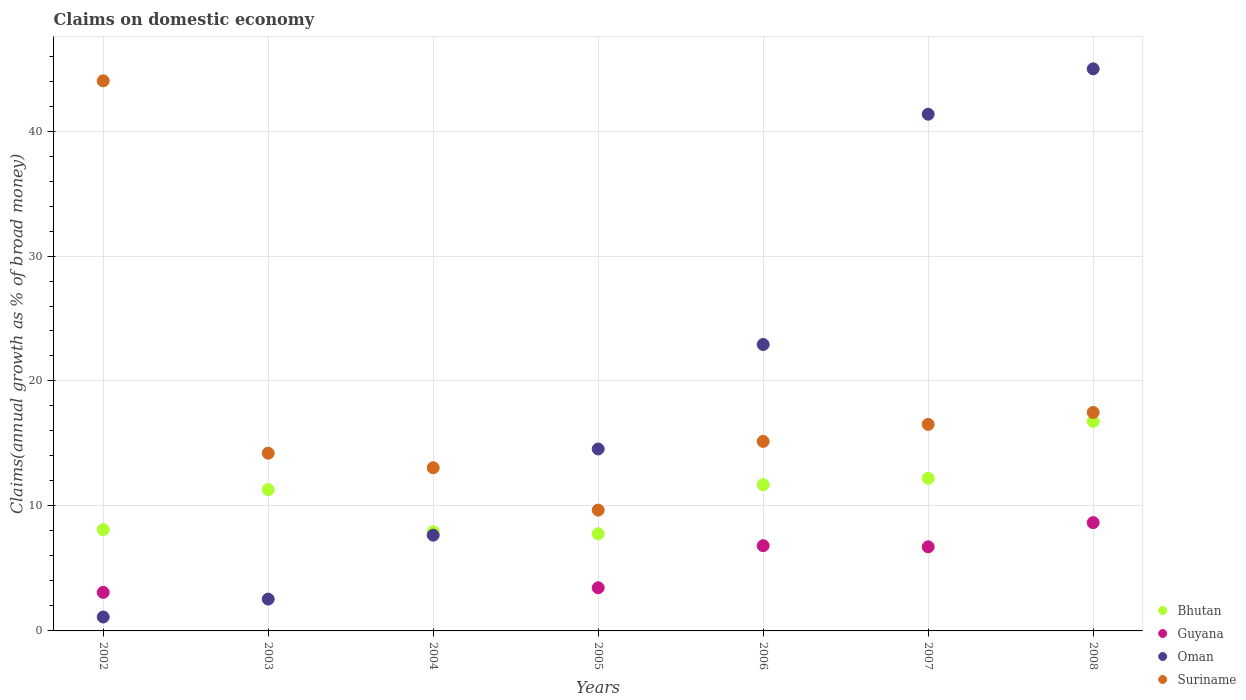Is the number of dotlines equal to the number of legend labels?
Offer a very short reply. No. What is the percentage of broad money claimed on domestic economy in Guyana in 2002?
Offer a very short reply. 3.08. Across all years, what is the maximum percentage of broad money claimed on domestic economy in Suriname?
Make the answer very short. 44.02. Across all years, what is the minimum percentage of broad money claimed on domestic economy in Oman?
Offer a very short reply. 1.11. What is the total percentage of broad money claimed on domestic economy in Oman in the graph?
Your answer should be compact. 135.13. What is the difference between the percentage of broad money claimed on domestic economy in Guyana in 2005 and that in 2006?
Provide a short and direct response. -3.37. What is the difference between the percentage of broad money claimed on domestic economy in Oman in 2003 and the percentage of broad money claimed on domestic economy in Guyana in 2007?
Your response must be concise. -4.18. What is the average percentage of broad money claimed on domestic economy in Suriname per year?
Your answer should be very brief. 18.59. In the year 2004, what is the difference between the percentage of broad money claimed on domestic economy in Bhutan and percentage of broad money claimed on domestic economy in Suriname?
Provide a succinct answer. -5.12. In how many years, is the percentage of broad money claimed on domestic economy in Guyana greater than 40 %?
Ensure brevity in your answer.  0. What is the ratio of the percentage of broad money claimed on domestic economy in Oman in 2003 to that in 2005?
Your answer should be very brief. 0.17. Is the percentage of broad money claimed on domestic economy in Suriname in 2005 less than that in 2006?
Provide a succinct answer. Yes. What is the difference between the highest and the second highest percentage of broad money claimed on domestic economy in Oman?
Keep it short and to the point. 3.63. What is the difference between the highest and the lowest percentage of broad money claimed on domestic economy in Bhutan?
Provide a short and direct response. 8.99. In how many years, is the percentage of broad money claimed on domestic economy in Suriname greater than the average percentage of broad money claimed on domestic economy in Suriname taken over all years?
Provide a succinct answer. 1. Is it the case that in every year, the sum of the percentage of broad money claimed on domestic economy in Bhutan and percentage of broad money claimed on domestic economy in Guyana  is greater than the sum of percentage of broad money claimed on domestic economy in Oman and percentage of broad money claimed on domestic economy in Suriname?
Your answer should be very brief. No. Is it the case that in every year, the sum of the percentage of broad money claimed on domestic economy in Guyana and percentage of broad money claimed on domestic economy in Oman  is greater than the percentage of broad money claimed on domestic economy in Bhutan?
Offer a terse response. No. Does the percentage of broad money claimed on domestic economy in Oman monotonically increase over the years?
Provide a succinct answer. Yes. Is the percentage of broad money claimed on domestic economy in Bhutan strictly greater than the percentage of broad money claimed on domestic economy in Suriname over the years?
Offer a very short reply. No. Is the percentage of broad money claimed on domestic economy in Oman strictly less than the percentage of broad money claimed on domestic economy in Bhutan over the years?
Your response must be concise. No. How many years are there in the graph?
Keep it short and to the point. 7. Are the values on the major ticks of Y-axis written in scientific E-notation?
Ensure brevity in your answer.  No. Does the graph contain grids?
Offer a terse response. Yes. Where does the legend appear in the graph?
Ensure brevity in your answer.  Bottom right. How are the legend labels stacked?
Your answer should be compact. Vertical. What is the title of the graph?
Your response must be concise. Claims on domestic economy. What is the label or title of the Y-axis?
Provide a short and direct response. Claims(annual growth as % of broad money). What is the Claims(annual growth as % of broad money) of Bhutan in 2002?
Ensure brevity in your answer.  8.11. What is the Claims(annual growth as % of broad money) in Guyana in 2002?
Your response must be concise. 3.08. What is the Claims(annual growth as % of broad money) in Oman in 2002?
Offer a terse response. 1.11. What is the Claims(annual growth as % of broad money) in Suriname in 2002?
Your response must be concise. 44.02. What is the Claims(annual growth as % of broad money) of Bhutan in 2003?
Provide a short and direct response. 11.31. What is the Claims(annual growth as % of broad money) in Oman in 2003?
Provide a succinct answer. 2.55. What is the Claims(annual growth as % of broad money) of Suriname in 2003?
Make the answer very short. 14.23. What is the Claims(annual growth as % of broad money) in Bhutan in 2004?
Give a very brief answer. 7.94. What is the Claims(annual growth as % of broad money) of Guyana in 2004?
Keep it short and to the point. 0. What is the Claims(annual growth as % of broad money) of Oman in 2004?
Keep it short and to the point. 7.66. What is the Claims(annual growth as % of broad money) of Suriname in 2004?
Your answer should be compact. 13.06. What is the Claims(annual growth as % of broad money) of Bhutan in 2005?
Give a very brief answer. 7.77. What is the Claims(annual growth as % of broad money) in Guyana in 2005?
Provide a succinct answer. 3.46. What is the Claims(annual growth as % of broad money) of Oman in 2005?
Your answer should be compact. 14.56. What is the Claims(annual growth as % of broad money) of Suriname in 2005?
Give a very brief answer. 9.67. What is the Claims(annual growth as % of broad money) of Bhutan in 2006?
Your response must be concise. 11.7. What is the Claims(annual growth as % of broad money) of Guyana in 2006?
Make the answer very short. 6.82. What is the Claims(annual growth as % of broad money) in Oman in 2006?
Ensure brevity in your answer.  22.92. What is the Claims(annual growth as % of broad money) in Suriname in 2006?
Your answer should be compact. 15.16. What is the Claims(annual growth as % of broad money) in Bhutan in 2007?
Make the answer very short. 12.21. What is the Claims(annual growth as % of broad money) of Guyana in 2007?
Provide a short and direct response. 6.73. What is the Claims(annual growth as % of broad money) in Oman in 2007?
Give a very brief answer. 41.35. What is the Claims(annual growth as % of broad money) of Suriname in 2007?
Offer a terse response. 16.53. What is the Claims(annual growth as % of broad money) of Bhutan in 2008?
Your response must be concise. 16.77. What is the Claims(annual growth as % of broad money) in Guyana in 2008?
Provide a short and direct response. 8.67. What is the Claims(annual growth as % of broad money) of Oman in 2008?
Give a very brief answer. 44.98. What is the Claims(annual growth as % of broad money) in Suriname in 2008?
Provide a short and direct response. 17.48. Across all years, what is the maximum Claims(annual growth as % of broad money) of Bhutan?
Your answer should be very brief. 16.77. Across all years, what is the maximum Claims(annual growth as % of broad money) of Guyana?
Your response must be concise. 8.67. Across all years, what is the maximum Claims(annual growth as % of broad money) of Oman?
Your response must be concise. 44.98. Across all years, what is the maximum Claims(annual growth as % of broad money) in Suriname?
Give a very brief answer. 44.02. Across all years, what is the minimum Claims(annual growth as % of broad money) of Bhutan?
Offer a very short reply. 7.77. Across all years, what is the minimum Claims(annual growth as % of broad money) of Oman?
Provide a succinct answer. 1.11. Across all years, what is the minimum Claims(annual growth as % of broad money) of Suriname?
Provide a short and direct response. 9.67. What is the total Claims(annual growth as % of broad money) of Bhutan in the graph?
Your answer should be compact. 75.81. What is the total Claims(annual growth as % of broad money) in Guyana in the graph?
Your answer should be compact. 28.76. What is the total Claims(annual growth as % of broad money) of Oman in the graph?
Make the answer very short. 135.13. What is the total Claims(annual growth as % of broad money) in Suriname in the graph?
Keep it short and to the point. 130.14. What is the difference between the Claims(annual growth as % of broad money) in Bhutan in 2002 and that in 2003?
Provide a succinct answer. -3.2. What is the difference between the Claims(annual growth as % of broad money) of Oman in 2002 and that in 2003?
Keep it short and to the point. -1.43. What is the difference between the Claims(annual growth as % of broad money) of Suriname in 2002 and that in 2003?
Your answer should be very brief. 29.79. What is the difference between the Claims(annual growth as % of broad money) of Bhutan in 2002 and that in 2004?
Make the answer very short. 0.17. What is the difference between the Claims(annual growth as % of broad money) in Oman in 2002 and that in 2004?
Make the answer very short. -6.55. What is the difference between the Claims(annual growth as % of broad money) of Suriname in 2002 and that in 2004?
Offer a terse response. 30.96. What is the difference between the Claims(annual growth as % of broad money) in Bhutan in 2002 and that in 2005?
Give a very brief answer. 0.33. What is the difference between the Claims(annual growth as % of broad money) in Guyana in 2002 and that in 2005?
Offer a very short reply. -0.37. What is the difference between the Claims(annual growth as % of broad money) of Oman in 2002 and that in 2005?
Offer a very short reply. -13.45. What is the difference between the Claims(annual growth as % of broad money) in Suriname in 2002 and that in 2005?
Provide a succinct answer. 34.35. What is the difference between the Claims(annual growth as % of broad money) of Bhutan in 2002 and that in 2006?
Make the answer very short. -3.6. What is the difference between the Claims(annual growth as % of broad money) of Guyana in 2002 and that in 2006?
Make the answer very short. -3.74. What is the difference between the Claims(annual growth as % of broad money) of Oman in 2002 and that in 2006?
Your answer should be very brief. -21.81. What is the difference between the Claims(annual growth as % of broad money) of Suriname in 2002 and that in 2006?
Offer a very short reply. 28.86. What is the difference between the Claims(annual growth as % of broad money) in Bhutan in 2002 and that in 2007?
Ensure brevity in your answer.  -4.11. What is the difference between the Claims(annual growth as % of broad money) in Guyana in 2002 and that in 2007?
Provide a short and direct response. -3.65. What is the difference between the Claims(annual growth as % of broad money) of Oman in 2002 and that in 2007?
Provide a succinct answer. -40.23. What is the difference between the Claims(annual growth as % of broad money) in Suriname in 2002 and that in 2007?
Your answer should be very brief. 27.49. What is the difference between the Claims(annual growth as % of broad money) of Bhutan in 2002 and that in 2008?
Provide a succinct answer. -8.66. What is the difference between the Claims(annual growth as % of broad money) of Guyana in 2002 and that in 2008?
Your answer should be very brief. -5.58. What is the difference between the Claims(annual growth as % of broad money) of Oman in 2002 and that in 2008?
Your answer should be compact. -43.86. What is the difference between the Claims(annual growth as % of broad money) of Suriname in 2002 and that in 2008?
Make the answer very short. 26.54. What is the difference between the Claims(annual growth as % of broad money) of Bhutan in 2003 and that in 2004?
Give a very brief answer. 3.37. What is the difference between the Claims(annual growth as % of broad money) of Oman in 2003 and that in 2004?
Provide a short and direct response. -5.12. What is the difference between the Claims(annual growth as % of broad money) in Suriname in 2003 and that in 2004?
Make the answer very short. 1.17. What is the difference between the Claims(annual growth as % of broad money) of Bhutan in 2003 and that in 2005?
Provide a short and direct response. 3.54. What is the difference between the Claims(annual growth as % of broad money) of Oman in 2003 and that in 2005?
Provide a succinct answer. -12.01. What is the difference between the Claims(annual growth as % of broad money) of Suriname in 2003 and that in 2005?
Offer a terse response. 4.56. What is the difference between the Claims(annual growth as % of broad money) in Bhutan in 2003 and that in 2006?
Offer a very short reply. -0.39. What is the difference between the Claims(annual growth as % of broad money) of Oman in 2003 and that in 2006?
Provide a short and direct response. -20.37. What is the difference between the Claims(annual growth as % of broad money) in Suriname in 2003 and that in 2006?
Your answer should be compact. -0.94. What is the difference between the Claims(annual growth as % of broad money) in Bhutan in 2003 and that in 2007?
Offer a very short reply. -0.91. What is the difference between the Claims(annual growth as % of broad money) in Oman in 2003 and that in 2007?
Your response must be concise. -38.8. What is the difference between the Claims(annual growth as % of broad money) in Suriname in 2003 and that in 2007?
Your answer should be very brief. -2.3. What is the difference between the Claims(annual growth as % of broad money) in Bhutan in 2003 and that in 2008?
Your answer should be very brief. -5.46. What is the difference between the Claims(annual growth as % of broad money) of Oman in 2003 and that in 2008?
Give a very brief answer. -42.43. What is the difference between the Claims(annual growth as % of broad money) in Suriname in 2003 and that in 2008?
Your response must be concise. -3.26. What is the difference between the Claims(annual growth as % of broad money) in Bhutan in 2004 and that in 2005?
Keep it short and to the point. 0.17. What is the difference between the Claims(annual growth as % of broad money) of Oman in 2004 and that in 2005?
Provide a short and direct response. -6.9. What is the difference between the Claims(annual growth as % of broad money) of Suriname in 2004 and that in 2005?
Make the answer very short. 3.39. What is the difference between the Claims(annual growth as % of broad money) of Bhutan in 2004 and that in 2006?
Your answer should be very brief. -3.76. What is the difference between the Claims(annual growth as % of broad money) of Oman in 2004 and that in 2006?
Provide a succinct answer. -15.26. What is the difference between the Claims(annual growth as % of broad money) in Suriname in 2004 and that in 2006?
Give a very brief answer. -2.11. What is the difference between the Claims(annual growth as % of broad money) in Bhutan in 2004 and that in 2007?
Keep it short and to the point. -4.28. What is the difference between the Claims(annual growth as % of broad money) of Oman in 2004 and that in 2007?
Your answer should be compact. -33.68. What is the difference between the Claims(annual growth as % of broad money) in Suriname in 2004 and that in 2007?
Offer a terse response. -3.47. What is the difference between the Claims(annual growth as % of broad money) of Bhutan in 2004 and that in 2008?
Make the answer very short. -8.83. What is the difference between the Claims(annual growth as % of broad money) of Oman in 2004 and that in 2008?
Give a very brief answer. -37.31. What is the difference between the Claims(annual growth as % of broad money) of Suriname in 2004 and that in 2008?
Your answer should be compact. -4.43. What is the difference between the Claims(annual growth as % of broad money) in Bhutan in 2005 and that in 2006?
Provide a short and direct response. -3.93. What is the difference between the Claims(annual growth as % of broad money) of Guyana in 2005 and that in 2006?
Your response must be concise. -3.37. What is the difference between the Claims(annual growth as % of broad money) in Oman in 2005 and that in 2006?
Ensure brevity in your answer.  -8.36. What is the difference between the Claims(annual growth as % of broad money) in Suriname in 2005 and that in 2006?
Your response must be concise. -5.5. What is the difference between the Claims(annual growth as % of broad money) in Bhutan in 2005 and that in 2007?
Offer a very short reply. -4.44. What is the difference between the Claims(annual growth as % of broad money) in Guyana in 2005 and that in 2007?
Provide a succinct answer. -3.27. What is the difference between the Claims(annual growth as % of broad money) in Oman in 2005 and that in 2007?
Offer a very short reply. -26.79. What is the difference between the Claims(annual growth as % of broad money) of Suriname in 2005 and that in 2007?
Provide a succinct answer. -6.86. What is the difference between the Claims(annual growth as % of broad money) in Bhutan in 2005 and that in 2008?
Provide a short and direct response. -8.99. What is the difference between the Claims(annual growth as % of broad money) in Guyana in 2005 and that in 2008?
Make the answer very short. -5.21. What is the difference between the Claims(annual growth as % of broad money) of Oman in 2005 and that in 2008?
Offer a very short reply. -30.42. What is the difference between the Claims(annual growth as % of broad money) of Suriname in 2005 and that in 2008?
Offer a terse response. -7.82. What is the difference between the Claims(annual growth as % of broad money) of Bhutan in 2006 and that in 2007?
Your response must be concise. -0.51. What is the difference between the Claims(annual growth as % of broad money) of Guyana in 2006 and that in 2007?
Your answer should be compact. 0.09. What is the difference between the Claims(annual growth as % of broad money) in Oman in 2006 and that in 2007?
Provide a short and direct response. -18.43. What is the difference between the Claims(annual growth as % of broad money) in Suriname in 2006 and that in 2007?
Your answer should be very brief. -1.36. What is the difference between the Claims(annual growth as % of broad money) in Bhutan in 2006 and that in 2008?
Offer a terse response. -5.06. What is the difference between the Claims(annual growth as % of broad money) in Guyana in 2006 and that in 2008?
Your answer should be very brief. -1.85. What is the difference between the Claims(annual growth as % of broad money) of Oman in 2006 and that in 2008?
Your answer should be very brief. -22.06. What is the difference between the Claims(annual growth as % of broad money) in Suriname in 2006 and that in 2008?
Give a very brief answer. -2.32. What is the difference between the Claims(annual growth as % of broad money) of Bhutan in 2007 and that in 2008?
Your response must be concise. -4.55. What is the difference between the Claims(annual growth as % of broad money) of Guyana in 2007 and that in 2008?
Give a very brief answer. -1.94. What is the difference between the Claims(annual growth as % of broad money) of Oman in 2007 and that in 2008?
Provide a short and direct response. -3.63. What is the difference between the Claims(annual growth as % of broad money) in Suriname in 2007 and that in 2008?
Offer a very short reply. -0.96. What is the difference between the Claims(annual growth as % of broad money) in Bhutan in 2002 and the Claims(annual growth as % of broad money) in Oman in 2003?
Offer a very short reply. 5.56. What is the difference between the Claims(annual growth as % of broad money) in Bhutan in 2002 and the Claims(annual growth as % of broad money) in Suriname in 2003?
Provide a succinct answer. -6.12. What is the difference between the Claims(annual growth as % of broad money) in Guyana in 2002 and the Claims(annual growth as % of broad money) in Oman in 2003?
Provide a short and direct response. 0.54. What is the difference between the Claims(annual growth as % of broad money) of Guyana in 2002 and the Claims(annual growth as % of broad money) of Suriname in 2003?
Give a very brief answer. -11.14. What is the difference between the Claims(annual growth as % of broad money) of Oman in 2002 and the Claims(annual growth as % of broad money) of Suriname in 2003?
Provide a short and direct response. -13.11. What is the difference between the Claims(annual growth as % of broad money) of Bhutan in 2002 and the Claims(annual growth as % of broad money) of Oman in 2004?
Provide a short and direct response. 0.44. What is the difference between the Claims(annual growth as % of broad money) in Bhutan in 2002 and the Claims(annual growth as % of broad money) in Suriname in 2004?
Offer a very short reply. -4.95. What is the difference between the Claims(annual growth as % of broad money) of Guyana in 2002 and the Claims(annual growth as % of broad money) of Oman in 2004?
Provide a succinct answer. -4.58. What is the difference between the Claims(annual growth as % of broad money) in Guyana in 2002 and the Claims(annual growth as % of broad money) in Suriname in 2004?
Provide a short and direct response. -9.97. What is the difference between the Claims(annual growth as % of broad money) in Oman in 2002 and the Claims(annual growth as % of broad money) in Suriname in 2004?
Provide a succinct answer. -11.94. What is the difference between the Claims(annual growth as % of broad money) of Bhutan in 2002 and the Claims(annual growth as % of broad money) of Guyana in 2005?
Provide a short and direct response. 4.65. What is the difference between the Claims(annual growth as % of broad money) in Bhutan in 2002 and the Claims(annual growth as % of broad money) in Oman in 2005?
Your response must be concise. -6.45. What is the difference between the Claims(annual growth as % of broad money) of Bhutan in 2002 and the Claims(annual growth as % of broad money) of Suriname in 2005?
Provide a succinct answer. -1.56. What is the difference between the Claims(annual growth as % of broad money) in Guyana in 2002 and the Claims(annual growth as % of broad money) in Oman in 2005?
Your response must be concise. -11.48. What is the difference between the Claims(annual growth as % of broad money) of Guyana in 2002 and the Claims(annual growth as % of broad money) of Suriname in 2005?
Ensure brevity in your answer.  -6.58. What is the difference between the Claims(annual growth as % of broad money) of Oman in 2002 and the Claims(annual growth as % of broad money) of Suriname in 2005?
Your response must be concise. -8.55. What is the difference between the Claims(annual growth as % of broad money) of Bhutan in 2002 and the Claims(annual growth as % of broad money) of Guyana in 2006?
Offer a terse response. 1.29. What is the difference between the Claims(annual growth as % of broad money) in Bhutan in 2002 and the Claims(annual growth as % of broad money) in Oman in 2006?
Provide a short and direct response. -14.81. What is the difference between the Claims(annual growth as % of broad money) of Bhutan in 2002 and the Claims(annual growth as % of broad money) of Suriname in 2006?
Keep it short and to the point. -7.06. What is the difference between the Claims(annual growth as % of broad money) of Guyana in 2002 and the Claims(annual growth as % of broad money) of Oman in 2006?
Your answer should be very brief. -19.84. What is the difference between the Claims(annual growth as % of broad money) of Guyana in 2002 and the Claims(annual growth as % of broad money) of Suriname in 2006?
Offer a very short reply. -12.08. What is the difference between the Claims(annual growth as % of broad money) of Oman in 2002 and the Claims(annual growth as % of broad money) of Suriname in 2006?
Provide a succinct answer. -14.05. What is the difference between the Claims(annual growth as % of broad money) of Bhutan in 2002 and the Claims(annual growth as % of broad money) of Guyana in 2007?
Give a very brief answer. 1.38. What is the difference between the Claims(annual growth as % of broad money) in Bhutan in 2002 and the Claims(annual growth as % of broad money) in Oman in 2007?
Provide a short and direct response. -33.24. What is the difference between the Claims(annual growth as % of broad money) in Bhutan in 2002 and the Claims(annual growth as % of broad money) in Suriname in 2007?
Offer a terse response. -8.42. What is the difference between the Claims(annual growth as % of broad money) of Guyana in 2002 and the Claims(annual growth as % of broad money) of Oman in 2007?
Offer a terse response. -38.26. What is the difference between the Claims(annual growth as % of broad money) of Guyana in 2002 and the Claims(annual growth as % of broad money) of Suriname in 2007?
Your answer should be very brief. -13.44. What is the difference between the Claims(annual growth as % of broad money) of Oman in 2002 and the Claims(annual growth as % of broad money) of Suriname in 2007?
Your answer should be very brief. -15.41. What is the difference between the Claims(annual growth as % of broad money) in Bhutan in 2002 and the Claims(annual growth as % of broad money) in Guyana in 2008?
Your response must be concise. -0.56. What is the difference between the Claims(annual growth as % of broad money) of Bhutan in 2002 and the Claims(annual growth as % of broad money) of Oman in 2008?
Keep it short and to the point. -36.87. What is the difference between the Claims(annual growth as % of broad money) in Bhutan in 2002 and the Claims(annual growth as % of broad money) in Suriname in 2008?
Provide a succinct answer. -9.37. What is the difference between the Claims(annual growth as % of broad money) of Guyana in 2002 and the Claims(annual growth as % of broad money) of Oman in 2008?
Offer a terse response. -41.89. What is the difference between the Claims(annual growth as % of broad money) in Guyana in 2002 and the Claims(annual growth as % of broad money) in Suriname in 2008?
Give a very brief answer. -14.4. What is the difference between the Claims(annual growth as % of broad money) of Oman in 2002 and the Claims(annual growth as % of broad money) of Suriname in 2008?
Make the answer very short. -16.37. What is the difference between the Claims(annual growth as % of broad money) in Bhutan in 2003 and the Claims(annual growth as % of broad money) in Oman in 2004?
Make the answer very short. 3.65. What is the difference between the Claims(annual growth as % of broad money) of Bhutan in 2003 and the Claims(annual growth as % of broad money) of Suriname in 2004?
Provide a short and direct response. -1.75. What is the difference between the Claims(annual growth as % of broad money) of Oman in 2003 and the Claims(annual growth as % of broad money) of Suriname in 2004?
Your answer should be very brief. -10.51. What is the difference between the Claims(annual growth as % of broad money) in Bhutan in 2003 and the Claims(annual growth as % of broad money) in Guyana in 2005?
Provide a succinct answer. 7.85. What is the difference between the Claims(annual growth as % of broad money) of Bhutan in 2003 and the Claims(annual growth as % of broad money) of Oman in 2005?
Offer a terse response. -3.25. What is the difference between the Claims(annual growth as % of broad money) of Bhutan in 2003 and the Claims(annual growth as % of broad money) of Suriname in 2005?
Ensure brevity in your answer.  1.64. What is the difference between the Claims(annual growth as % of broad money) of Oman in 2003 and the Claims(annual growth as % of broad money) of Suriname in 2005?
Provide a short and direct response. -7.12. What is the difference between the Claims(annual growth as % of broad money) of Bhutan in 2003 and the Claims(annual growth as % of broad money) of Guyana in 2006?
Your response must be concise. 4.49. What is the difference between the Claims(annual growth as % of broad money) in Bhutan in 2003 and the Claims(annual growth as % of broad money) in Oman in 2006?
Offer a very short reply. -11.61. What is the difference between the Claims(annual growth as % of broad money) of Bhutan in 2003 and the Claims(annual growth as % of broad money) of Suriname in 2006?
Give a very brief answer. -3.86. What is the difference between the Claims(annual growth as % of broad money) in Oman in 2003 and the Claims(annual growth as % of broad money) in Suriname in 2006?
Your answer should be compact. -12.62. What is the difference between the Claims(annual growth as % of broad money) in Bhutan in 2003 and the Claims(annual growth as % of broad money) in Guyana in 2007?
Keep it short and to the point. 4.58. What is the difference between the Claims(annual growth as % of broad money) in Bhutan in 2003 and the Claims(annual growth as % of broad money) in Oman in 2007?
Keep it short and to the point. -30.04. What is the difference between the Claims(annual growth as % of broad money) in Bhutan in 2003 and the Claims(annual growth as % of broad money) in Suriname in 2007?
Offer a terse response. -5.22. What is the difference between the Claims(annual growth as % of broad money) of Oman in 2003 and the Claims(annual growth as % of broad money) of Suriname in 2007?
Give a very brief answer. -13.98. What is the difference between the Claims(annual growth as % of broad money) of Bhutan in 2003 and the Claims(annual growth as % of broad money) of Guyana in 2008?
Provide a succinct answer. 2.64. What is the difference between the Claims(annual growth as % of broad money) in Bhutan in 2003 and the Claims(annual growth as % of broad money) in Oman in 2008?
Your answer should be very brief. -33.67. What is the difference between the Claims(annual growth as % of broad money) of Bhutan in 2003 and the Claims(annual growth as % of broad money) of Suriname in 2008?
Offer a very short reply. -6.17. What is the difference between the Claims(annual growth as % of broad money) in Oman in 2003 and the Claims(annual growth as % of broad money) in Suriname in 2008?
Keep it short and to the point. -14.93. What is the difference between the Claims(annual growth as % of broad money) in Bhutan in 2004 and the Claims(annual growth as % of broad money) in Guyana in 2005?
Ensure brevity in your answer.  4.48. What is the difference between the Claims(annual growth as % of broad money) of Bhutan in 2004 and the Claims(annual growth as % of broad money) of Oman in 2005?
Provide a succinct answer. -6.62. What is the difference between the Claims(annual growth as % of broad money) in Bhutan in 2004 and the Claims(annual growth as % of broad money) in Suriname in 2005?
Provide a succinct answer. -1.73. What is the difference between the Claims(annual growth as % of broad money) of Oman in 2004 and the Claims(annual growth as % of broad money) of Suriname in 2005?
Make the answer very short. -2. What is the difference between the Claims(annual growth as % of broad money) in Bhutan in 2004 and the Claims(annual growth as % of broad money) in Guyana in 2006?
Provide a succinct answer. 1.12. What is the difference between the Claims(annual growth as % of broad money) of Bhutan in 2004 and the Claims(annual growth as % of broad money) of Oman in 2006?
Keep it short and to the point. -14.98. What is the difference between the Claims(annual growth as % of broad money) in Bhutan in 2004 and the Claims(annual growth as % of broad money) in Suriname in 2006?
Provide a succinct answer. -7.23. What is the difference between the Claims(annual growth as % of broad money) of Oman in 2004 and the Claims(annual growth as % of broad money) of Suriname in 2006?
Provide a short and direct response. -7.5. What is the difference between the Claims(annual growth as % of broad money) in Bhutan in 2004 and the Claims(annual growth as % of broad money) in Guyana in 2007?
Provide a short and direct response. 1.21. What is the difference between the Claims(annual growth as % of broad money) of Bhutan in 2004 and the Claims(annual growth as % of broad money) of Oman in 2007?
Ensure brevity in your answer.  -33.41. What is the difference between the Claims(annual growth as % of broad money) of Bhutan in 2004 and the Claims(annual growth as % of broad money) of Suriname in 2007?
Provide a succinct answer. -8.59. What is the difference between the Claims(annual growth as % of broad money) in Oman in 2004 and the Claims(annual growth as % of broad money) in Suriname in 2007?
Your response must be concise. -8.86. What is the difference between the Claims(annual growth as % of broad money) of Bhutan in 2004 and the Claims(annual growth as % of broad money) of Guyana in 2008?
Offer a terse response. -0.73. What is the difference between the Claims(annual growth as % of broad money) of Bhutan in 2004 and the Claims(annual growth as % of broad money) of Oman in 2008?
Make the answer very short. -37.04. What is the difference between the Claims(annual growth as % of broad money) of Bhutan in 2004 and the Claims(annual growth as % of broad money) of Suriname in 2008?
Offer a terse response. -9.54. What is the difference between the Claims(annual growth as % of broad money) in Oman in 2004 and the Claims(annual growth as % of broad money) in Suriname in 2008?
Keep it short and to the point. -9.82. What is the difference between the Claims(annual growth as % of broad money) of Bhutan in 2005 and the Claims(annual growth as % of broad money) of Guyana in 2006?
Your response must be concise. 0.95. What is the difference between the Claims(annual growth as % of broad money) of Bhutan in 2005 and the Claims(annual growth as % of broad money) of Oman in 2006?
Offer a very short reply. -15.15. What is the difference between the Claims(annual growth as % of broad money) in Bhutan in 2005 and the Claims(annual growth as % of broad money) in Suriname in 2006?
Offer a terse response. -7.39. What is the difference between the Claims(annual growth as % of broad money) of Guyana in 2005 and the Claims(annual growth as % of broad money) of Oman in 2006?
Offer a very short reply. -19.46. What is the difference between the Claims(annual growth as % of broad money) of Guyana in 2005 and the Claims(annual growth as % of broad money) of Suriname in 2006?
Give a very brief answer. -11.71. What is the difference between the Claims(annual growth as % of broad money) in Oman in 2005 and the Claims(annual growth as % of broad money) in Suriname in 2006?
Provide a succinct answer. -0.6. What is the difference between the Claims(annual growth as % of broad money) in Bhutan in 2005 and the Claims(annual growth as % of broad money) in Guyana in 2007?
Give a very brief answer. 1.04. What is the difference between the Claims(annual growth as % of broad money) of Bhutan in 2005 and the Claims(annual growth as % of broad money) of Oman in 2007?
Provide a short and direct response. -33.58. What is the difference between the Claims(annual growth as % of broad money) of Bhutan in 2005 and the Claims(annual growth as % of broad money) of Suriname in 2007?
Provide a succinct answer. -8.75. What is the difference between the Claims(annual growth as % of broad money) of Guyana in 2005 and the Claims(annual growth as % of broad money) of Oman in 2007?
Your response must be concise. -37.89. What is the difference between the Claims(annual growth as % of broad money) of Guyana in 2005 and the Claims(annual growth as % of broad money) of Suriname in 2007?
Your answer should be compact. -13.07. What is the difference between the Claims(annual growth as % of broad money) in Oman in 2005 and the Claims(annual growth as % of broad money) in Suriname in 2007?
Provide a short and direct response. -1.97. What is the difference between the Claims(annual growth as % of broad money) in Bhutan in 2005 and the Claims(annual growth as % of broad money) in Guyana in 2008?
Keep it short and to the point. -0.89. What is the difference between the Claims(annual growth as % of broad money) in Bhutan in 2005 and the Claims(annual growth as % of broad money) in Oman in 2008?
Offer a very short reply. -37.2. What is the difference between the Claims(annual growth as % of broad money) of Bhutan in 2005 and the Claims(annual growth as % of broad money) of Suriname in 2008?
Provide a succinct answer. -9.71. What is the difference between the Claims(annual growth as % of broad money) of Guyana in 2005 and the Claims(annual growth as % of broad money) of Oman in 2008?
Offer a terse response. -41.52. What is the difference between the Claims(annual growth as % of broad money) in Guyana in 2005 and the Claims(annual growth as % of broad money) in Suriname in 2008?
Ensure brevity in your answer.  -14.03. What is the difference between the Claims(annual growth as % of broad money) of Oman in 2005 and the Claims(annual growth as % of broad money) of Suriname in 2008?
Your response must be concise. -2.92. What is the difference between the Claims(annual growth as % of broad money) of Bhutan in 2006 and the Claims(annual growth as % of broad money) of Guyana in 2007?
Give a very brief answer. 4.97. What is the difference between the Claims(annual growth as % of broad money) of Bhutan in 2006 and the Claims(annual growth as % of broad money) of Oman in 2007?
Your response must be concise. -29.65. What is the difference between the Claims(annual growth as % of broad money) in Bhutan in 2006 and the Claims(annual growth as % of broad money) in Suriname in 2007?
Your response must be concise. -4.82. What is the difference between the Claims(annual growth as % of broad money) in Guyana in 2006 and the Claims(annual growth as % of broad money) in Oman in 2007?
Offer a very short reply. -34.53. What is the difference between the Claims(annual growth as % of broad money) of Guyana in 2006 and the Claims(annual growth as % of broad money) of Suriname in 2007?
Your answer should be compact. -9.71. What is the difference between the Claims(annual growth as % of broad money) of Oman in 2006 and the Claims(annual growth as % of broad money) of Suriname in 2007?
Offer a very short reply. 6.39. What is the difference between the Claims(annual growth as % of broad money) in Bhutan in 2006 and the Claims(annual growth as % of broad money) in Guyana in 2008?
Offer a very short reply. 3.04. What is the difference between the Claims(annual growth as % of broad money) in Bhutan in 2006 and the Claims(annual growth as % of broad money) in Oman in 2008?
Give a very brief answer. -33.27. What is the difference between the Claims(annual growth as % of broad money) of Bhutan in 2006 and the Claims(annual growth as % of broad money) of Suriname in 2008?
Your response must be concise. -5.78. What is the difference between the Claims(annual growth as % of broad money) of Guyana in 2006 and the Claims(annual growth as % of broad money) of Oman in 2008?
Provide a succinct answer. -38.16. What is the difference between the Claims(annual growth as % of broad money) of Guyana in 2006 and the Claims(annual growth as % of broad money) of Suriname in 2008?
Offer a very short reply. -10.66. What is the difference between the Claims(annual growth as % of broad money) in Oman in 2006 and the Claims(annual growth as % of broad money) in Suriname in 2008?
Your answer should be compact. 5.44. What is the difference between the Claims(annual growth as % of broad money) of Bhutan in 2007 and the Claims(annual growth as % of broad money) of Guyana in 2008?
Provide a short and direct response. 3.55. What is the difference between the Claims(annual growth as % of broad money) in Bhutan in 2007 and the Claims(annual growth as % of broad money) in Oman in 2008?
Your response must be concise. -32.76. What is the difference between the Claims(annual growth as % of broad money) in Bhutan in 2007 and the Claims(annual growth as % of broad money) in Suriname in 2008?
Provide a succinct answer. -5.27. What is the difference between the Claims(annual growth as % of broad money) of Guyana in 2007 and the Claims(annual growth as % of broad money) of Oman in 2008?
Provide a succinct answer. -38.25. What is the difference between the Claims(annual growth as % of broad money) in Guyana in 2007 and the Claims(annual growth as % of broad money) in Suriname in 2008?
Give a very brief answer. -10.75. What is the difference between the Claims(annual growth as % of broad money) in Oman in 2007 and the Claims(annual growth as % of broad money) in Suriname in 2008?
Your answer should be very brief. 23.87. What is the average Claims(annual growth as % of broad money) in Bhutan per year?
Make the answer very short. 10.83. What is the average Claims(annual growth as % of broad money) of Guyana per year?
Provide a short and direct response. 4.11. What is the average Claims(annual growth as % of broad money) of Oman per year?
Offer a terse response. 19.3. What is the average Claims(annual growth as % of broad money) in Suriname per year?
Give a very brief answer. 18.59. In the year 2002, what is the difference between the Claims(annual growth as % of broad money) of Bhutan and Claims(annual growth as % of broad money) of Guyana?
Give a very brief answer. 5.02. In the year 2002, what is the difference between the Claims(annual growth as % of broad money) of Bhutan and Claims(annual growth as % of broad money) of Oman?
Ensure brevity in your answer.  6.99. In the year 2002, what is the difference between the Claims(annual growth as % of broad money) in Bhutan and Claims(annual growth as % of broad money) in Suriname?
Offer a very short reply. -35.91. In the year 2002, what is the difference between the Claims(annual growth as % of broad money) of Guyana and Claims(annual growth as % of broad money) of Oman?
Provide a short and direct response. 1.97. In the year 2002, what is the difference between the Claims(annual growth as % of broad money) of Guyana and Claims(annual growth as % of broad money) of Suriname?
Your answer should be very brief. -40.94. In the year 2002, what is the difference between the Claims(annual growth as % of broad money) of Oman and Claims(annual growth as % of broad money) of Suriname?
Your answer should be compact. -42.91. In the year 2003, what is the difference between the Claims(annual growth as % of broad money) in Bhutan and Claims(annual growth as % of broad money) in Oman?
Offer a terse response. 8.76. In the year 2003, what is the difference between the Claims(annual growth as % of broad money) of Bhutan and Claims(annual growth as % of broad money) of Suriname?
Make the answer very short. -2.92. In the year 2003, what is the difference between the Claims(annual growth as % of broad money) in Oman and Claims(annual growth as % of broad money) in Suriname?
Keep it short and to the point. -11.68. In the year 2004, what is the difference between the Claims(annual growth as % of broad money) in Bhutan and Claims(annual growth as % of broad money) in Oman?
Your answer should be compact. 0.28. In the year 2004, what is the difference between the Claims(annual growth as % of broad money) of Bhutan and Claims(annual growth as % of broad money) of Suriname?
Provide a succinct answer. -5.12. In the year 2004, what is the difference between the Claims(annual growth as % of broad money) of Oman and Claims(annual growth as % of broad money) of Suriname?
Offer a terse response. -5.39. In the year 2005, what is the difference between the Claims(annual growth as % of broad money) in Bhutan and Claims(annual growth as % of broad money) in Guyana?
Your answer should be very brief. 4.32. In the year 2005, what is the difference between the Claims(annual growth as % of broad money) in Bhutan and Claims(annual growth as % of broad money) in Oman?
Ensure brevity in your answer.  -6.79. In the year 2005, what is the difference between the Claims(annual growth as % of broad money) in Bhutan and Claims(annual growth as % of broad money) in Suriname?
Your answer should be very brief. -1.89. In the year 2005, what is the difference between the Claims(annual growth as % of broad money) of Guyana and Claims(annual growth as % of broad money) of Oman?
Keep it short and to the point. -11.1. In the year 2005, what is the difference between the Claims(annual growth as % of broad money) in Guyana and Claims(annual growth as % of broad money) in Suriname?
Offer a terse response. -6.21. In the year 2005, what is the difference between the Claims(annual growth as % of broad money) in Oman and Claims(annual growth as % of broad money) in Suriname?
Keep it short and to the point. 4.89. In the year 2006, what is the difference between the Claims(annual growth as % of broad money) in Bhutan and Claims(annual growth as % of broad money) in Guyana?
Provide a succinct answer. 4.88. In the year 2006, what is the difference between the Claims(annual growth as % of broad money) of Bhutan and Claims(annual growth as % of broad money) of Oman?
Offer a terse response. -11.22. In the year 2006, what is the difference between the Claims(annual growth as % of broad money) of Bhutan and Claims(annual growth as % of broad money) of Suriname?
Ensure brevity in your answer.  -3.46. In the year 2006, what is the difference between the Claims(annual growth as % of broad money) of Guyana and Claims(annual growth as % of broad money) of Oman?
Provide a succinct answer. -16.1. In the year 2006, what is the difference between the Claims(annual growth as % of broad money) in Guyana and Claims(annual growth as % of broad money) in Suriname?
Offer a terse response. -8.34. In the year 2006, what is the difference between the Claims(annual growth as % of broad money) in Oman and Claims(annual growth as % of broad money) in Suriname?
Your response must be concise. 7.75. In the year 2007, what is the difference between the Claims(annual growth as % of broad money) of Bhutan and Claims(annual growth as % of broad money) of Guyana?
Make the answer very short. 5.48. In the year 2007, what is the difference between the Claims(annual growth as % of broad money) of Bhutan and Claims(annual growth as % of broad money) of Oman?
Offer a very short reply. -29.13. In the year 2007, what is the difference between the Claims(annual growth as % of broad money) in Bhutan and Claims(annual growth as % of broad money) in Suriname?
Make the answer very short. -4.31. In the year 2007, what is the difference between the Claims(annual growth as % of broad money) in Guyana and Claims(annual growth as % of broad money) in Oman?
Your answer should be very brief. -34.62. In the year 2007, what is the difference between the Claims(annual growth as % of broad money) in Guyana and Claims(annual growth as % of broad money) in Suriname?
Offer a terse response. -9.8. In the year 2007, what is the difference between the Claims(annual growth as % of broad money) of Oman and Claims(annual growth as % of broad money) of Suriname?
Your response must be concise. 24.82. In the year 2008, what is the difference between the Claims(annual growth as % of broad money) of Bhutan and Claims(annual growth as % of broad money) of Guyana?
Ensure brevity in your answer.  8.1. In the year 2008, what is the difference between the Claims(annual growth as % of broad money) of Bhutan and Claims(annual growth as % of broad money) of Oman?
Make the answer very short. -28.21. In the year 2008, what is the difference between the Claims(annual growth as % of broad money) of Bhutan and Claims(annual growth as % of broad money) of Suriname?
Offer a terse response. -0.72. In the year 2008, what is the difference between the Claims(annual growth as % of broad money) in Guyana and Claims(annual growth as % of broad money) in Oman?
Offer a very short reply. -36.31. In the year 2008, what is the difference between the Claims(annual growth as % of broad money) in Guyana and Claims(annual growth as % of broad money) in Suriname?
Ensure brevity in your answer.  -8.82. In the year 2008, what is the difference between the Claims(annual growth as % of broad money) of Oman and Claims(annual growth as % of broad money) of Suriname?
Your response must be concise. 27.49. What is the ratio of the Claims(annual growth as % of broad money) of Bhutan in 2002 to that in 2003?
Ensure brevity in your answer.  0.72. What is the ratio of the Claims(annual growth as % of broad money) in Oman in 2002 to that in 2003?
Make the answer very short. 0.44. What is the ratio of the Claims(annual growth as % of broad money) in Suriname in 2002 to that in 2003?
Keep it short and to the point. 3.09. What is the ratio of the Claims(annual growth as % of broad money) of Bhutan in 2002 to that in 2004?
Your answer should be compact. 1.02. What is the ratio of the Claims(annual growth as % of broad money) of Oman in 2002 to that in 2004?
Make the answer very short. 0.15. What is the ratio of the Claims(annual growth as % of broad money) of Suriname in 2002 to that in 2004?
Provide a succinct answer. 3.37. What is the ratio of the Claims(annual growth as % of broad money) of Bhutan in 2002 to that in 2005?
Keep it short and to the point. 1.04. What is the ratio of the Claims(annual growth as % of broad money) in Guyana in 2002 to that in 2005?
Offer a terse response. 0.89. What is the ratio of the Claims(annual growth as % of broad money) in Oman in 2002 to that in 2005?
Provide a succinct answer. 0.08. What is the ratio of the Claims(annual growth as % of broad money) of Suriname in 2002 to that in 2005?
Provide a succinct answer. 4.55. What is the ratio of the Claims(annual growth as % of broad money) of Bhutan in 2002 to that in 2006?
Ensure brevity in your answer.  0.69. What is the ratio of the Claims(annual growth as % of broad money) in Guyana in 2002 to that in 2006?
Your response must be concise. 0.45. What is the ratio of the Claims(annual growth as % of broad money) in Oman in 2002 to that in 2006?
Your answer should be compact. 0.05. What is the ratio of the Claims(annual growth as % of broad money) of Suriname in 2002 to that in 2006?
Your answer should be compact. 2.9. What is the ratio of the Claims(annual growth as % of broad money) in Bhutan in 2002 to that in 2007?
Your answer should be compact. 0.66. What is the ratio of the Claims(annual growth as % of broad money) of Guyana in 2002 to that in 2007?
Make the answer very short. 0.46. What is the ratio of the Claims(annual growth as % of broad money) of Oman in 2002 to that in 2007?
Keep it short and to the point. 0.03. What is the ratio of the Claims(annual growth as % of broad money) of Suriname in 2002 to that in 2007?
Make the answer very short. 2.66. What is the ratio of the Claims(annual growth as % of broad money) in Bhutan in 2002 to that in 2008?
Provide a short and direct response. 0.48. What is the ratio of the Claims(annual growth as % of broad money) in Guyana in 2002 to that in 2008?
Your answer should be compact. 0.36. What is the ratio of the Claims(annual growth as % of broad money) of Oman in 2002 to that in 2008?
Offer a very short reply. 0.02. What is the ratio of the Claims(annual growth as % of broad money) in Suriname in 2002 to that in 2008?
Provide a short and direct response. 2.52. What is the ratio of the Claims(annual growth as % of broad money) in Bhutan in 2003 to that in 2004?
Offer a very short reply. 1.42. What is the ratio of the Claims(annual growth as % of broad money) in Oman in 2003 to that in 2004?
Your answer should be very brief. 0.33. What is the ratio of the Claims(annual growth as % of broad money) of Suriname in 2003 to that in 2004?
Your answer should be very brief. 1.09. What is the ratio of the Claims(annual growth as % of broad money) of Bhutan in 2003 to that in 2005?
Your response must be concise. 1.45. What is the ratio of the Claims(annual growth as % of broad money) in Oman in 2003 to that in 2005?
Your response must be concise. 0.17. What is the ratio of the Claims(annual growth as % of broad money) of Suriname in 2003 to that in 2005?
Your response must be concise. 1.47. What is the ratio of the Claims(annual growth as % of broad money) in Bhutan in 2003 to that in 2006?
Keep it short and to the point. 0.97. What is the ratio of the Claims(annual growth as % of broad money) of Oman in 2003 to that in 2006?
Ensure brevity in your answer.  0.11. What is the ratio of the Claims(annual growth as % of broad money) in Suriname in 2003 to that in 2006?
Your answer should be compact. 0.94. What is the ratio of the Claims(annual growth as % of broad money) in Bhutan in 2003 to that in 2007?
Make the answer very short. 0.93. What is the ratio of the Claims(annual growth as % of broad money) of Oman in 2003 to that in 2007?
Your response must be concise. 0.06. What is the ratio of the Claims(annual growth as % of broad money) of Suriname in 2003 to that in 2007?
Offer a very short reply. 0.86. What is the ratio of the Claims(annual growth as % of broad money) of Bhutan in 2003 to that in 2008?
Ensure brevity in your answer.  0.67. What is the ratio of the Claims(annual growth as % of broad money) in Oman in 2003 to that in 2008?
Keep it short and to the point. 0.06. What is the ratio of the Claims(annual growth as % of broad money) of Suriname in 2003 to that in 2008?
Provide a succinct answer. 0.81. What is the ratio of the Claims(annual growth as % of broad money) in Bhutan in 2004 to that in 2005?
Give a very brief answer. 1.02. What is the ratio of the Claims(annual growth as % of broad money) of Oman in 2004 to that in 2005?
Your response must be concise. 0.53. What is the ratio of the Claims(annual growth as % of broad money) in Suriname in 2004 to that in 2005?
Your response must be concise. 1.35. What is the ratio of the Claims(annual growth as % of broad money) of Bhutan in 2004 to that in 2006?
Provide a succinct answer. 0.68. What is the ratio of the Claims(annual growth as % of broad money) in Oman in 2004 to that in 2006?
Ensure brevity in your answer.  0.33. What is the ratio of the Claims(annual growth as % of broad money) of Suriname in 2004 to that in 2006?
Your response must be concise. 0.86. What is the ratio of the Claims(annual growth as % of broad money) of Bhutan in 2004 to that in 2007?
Offer a terse response. 0.65. What is the ratio of the Claims(annual growth as % of broad money) in Oman in 2004 to that in 2007?
Provide a succinct answer. 0.19. What is the ratio of the Claims(annual growth as % of broad money) of Suriname in 2004 to that in 2007?
Your response must be concise. 0.79. What is the ratio of the Claims(annual growth as % of broad money) of Bhutan in 2004 to that in 2008?
Your response must be concise. 0.47. What is the ratio of the Claims(annual growth as % of broad money) of Oman in 2004 to that in 2008?
Offer a very short reply. 0.17. What is the ratio of the Claims(annual growth as % of broad money) of Suriname in 2004 to that in 2008?
Offer a very short reply. 0.75. What is the ratio of the Claims(annual growth as % of broad money) in Bhutan in 2005 to that in 2006?
Offer a terse response. 0.66. What is the ratio of the Claims(annual growth as % of broad money) of Guyana in 2005 to that in 2006?
Provide a succinct answer. 0.51. What is the ratio of the Claims(annual growth as % of broad money) of Oman in 2005 to that in 2006?
Your answer should be very brief. 0.64. What is the ratio of the Claims(annual growth as % of broad money) in Suriname in 2005 to that in 2006?
Your answer should be compact. 0.64. What is the ratio of the Claims(annual growth as % of broad money) of Bhutan in 2005 to that in 2007?
Offer a terse response. 0.64. What is the ratio of the Claims(annual growth as % of broad money) of Guyana in 2005 to that in 2007?
Your response must be concise. 0.51. What is the ratio of the Claims(annual growth as % of broad money) in Oman in 2005 to that in 2007?
Provide a short and direct response. 0.35. What is the ratio of the Claims(annual growth as % of broad money) of Suriname in 2005 to that in 2007?
Your answer should be compact. 0.58. What is the ratio of the Claims(annual growth as % of broad money) of Bhutan in 2005 to that in 2008?
Offer a very short reply. 0.46. What is the ratio of the Claims(annual growth as % of broad money) of Guyana in 2005 to that in 2008?
Keep it short and to the point. 0.4. What is the ratio of the Claims(annual growth as % of broad money) in Oman in 2005 to that in 2008?
Make the answer very short. 0.32. What is the ratio of the Claims(annual growth as % of broad money) in Suriname in 2005 to that in 2008?
Your response must be concise. 0.55. What is the ratio of the Claims(annual growth as % of broad money) of Bhutan in 2006 to that in 2007?
Make the answer very short. 0.96. What is the ratio of the Claims(annual growth as % of broad money) of Guyana in 2006 to that in 2007?
Offer a terse response. 1.01. What is the ratio of the Claims(annual growth as % of broad money) of Oman in 2006 to that in 2007?
Provide a succinct answer. 0.55. What is the ratio of the Claims(annual growth as % of broad money) of Suriname in 2006 to that in 2007?
Provide a short and direct response. 0.92. What is the ratio of the Claims(annual growth as % of broad money) in Bhutan in 2006 to that in 2008?
Provide a succinct answer. 0.7. What is the ratio of the Claims(annual growth as % of broad money) in Guyana in 2006 to that in 2008?
Your response must be concise. 0.79. What is the ratio of the Claims(annual growth as % of broad money) in Oman in 2006 to that in 2008?
Ensure brevity in your answer.  0.51. What is the ratio of the Claims(annual growth as % of broad money) in Suriname in 2006 to that in 2008?
Provide a short and direct response. 0.87. What is the ratio of the Claims(annual growth as % of broad money) of Bhutan in 2007 to that in 2008?
Keep it short and to the point. 0.73. What is the ratio of the Claims(annual growth as % of broad money) of Guyana in 2007 to that in 2008?
Give a very brief answer. 0.78. What is the ratio of the Claims(annual growth as % of broad money) of Oman in 2007 to that in 2008?
Make the answer very short. 0.92. What is the ratio of the Claims(annual growth as % of broad money) of Suriname in 2007 to that in 2008?
Your response must be concise. 0.95. What is the difference between the highest and the second highest Claims(annual growth as % of broad money) in Bhutan?
Ensure brevity in your answer.  4.55. What is the difference between the highest and the second highest Claims(annual growth as % of broad money) in Guyana?
Your answer should be very brief. 1.85. What is the difference between the highest and the second highest Claims(annual growth as % of broad money) in Oman?
Your response must be concise. 3.63. What is the difference between the highest and the second highest Claims(annual growth as % of broad money) of Suriname?
Your answer should be very brief. 26.54. What is the difference between the highest and the lowest Claims(annual growth as % of broad money) of Bhutan?
Your answer should be very brief. 8.99. What is the difference between the highest and the lowest Claims(annual growth as % of broad money) in Guyana?
Make the answer very short. 8.67. What is the difference between the highest and the lowest Claims(annual growth as % of broad money) in Oman?
Your answer should be compact. 43.86. What is the difference between the highest and the lowest Claims(annual growth as % of broad money) of Suriname?
Ensure brevity in your answer.  34.35. 